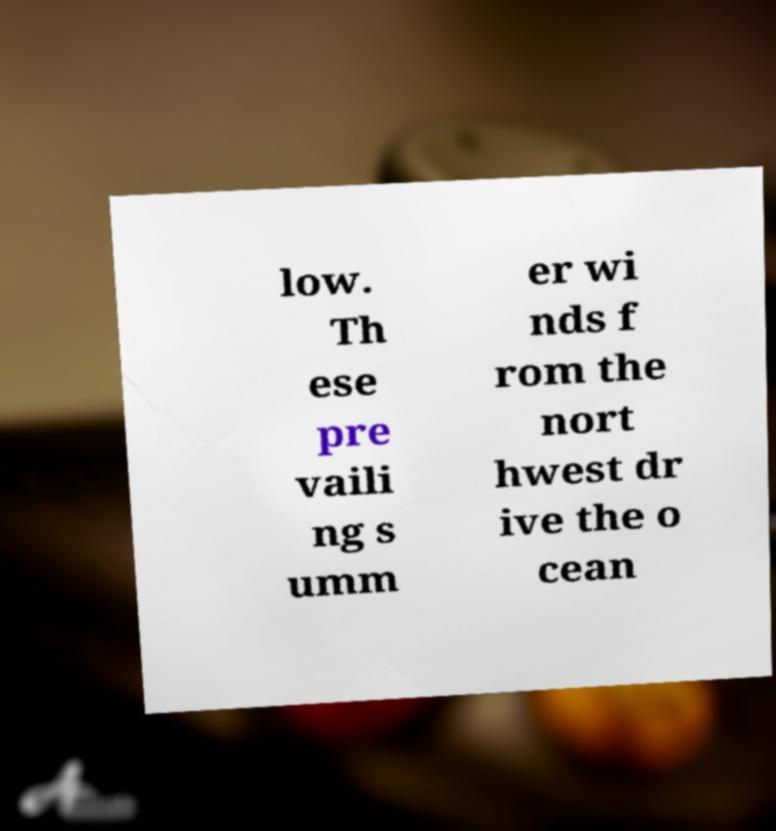Can you read and provide the text displayed in the image?This photo seems to have some interesting text. Can you extract and type it out for me? low. Th ese pre vaili ng s umm er wi nds f rom the nort hwest dr ive the o cean 